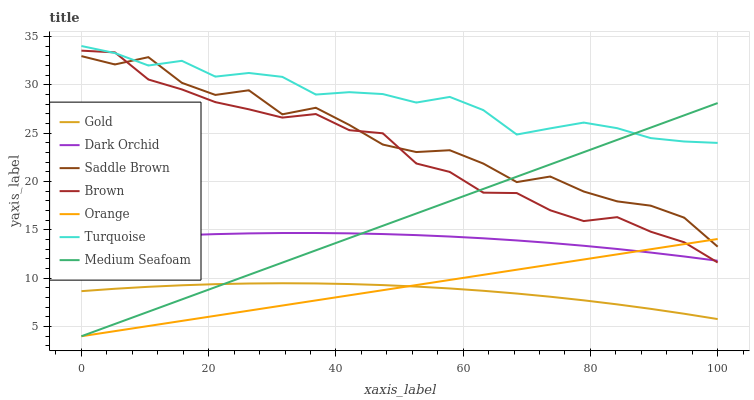Does Gold have the minimum area under the curve?
Answer yes or no. Yes. Does Turquoise have the maximum area under the curve?
Answer yes or no. Yes. Does Turquoise have the minimum area under the curve?
Answer yes or no. No. Does Gold have the maximum area under the curve?
Answer yes or no. No. Is Orange the smoothest?
Answer yes or no. Yes. Is Saddle Brown the roughest?
Answer yes or no. Yes. Is Turquoise the smoothest?
Answer yes or no. No. Is Turquoise the roughest?
Answer yes or no. No. Does Medium Seafoam have the lowest value?
Answer yes or no. Yes. Does Gold have the lowest value?
Answer yes or no. No. Does Turquoise have the highest value?
Answer yes or no. Yes. Does Gold have the highest value?
Answer yes or no. No. Is Gold less than Turquoise?
Answer yes or no. Yes. Is Saddle Brown greater than Dark Orchid?
Answer yes or no. Yes. Does Brown intersect Turquoise?
Answer yes or no. Yes. Is Brown less than Turquoise?
Answer yes or no. No. Is Brown greater than Turquoise?
Answer yes or no. No. Does Gold intersect Turquoise?
Answer yes or no. No. 